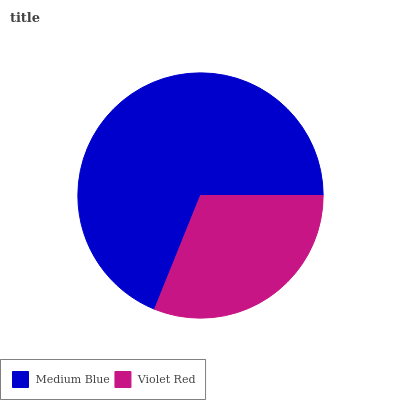Is Violet Red the minimum?
Answer yes or no. Yes. Is Medium Blue the maximum?
Answer yes or no. Yes. Is Violet Red the maximum?
Answer yes or no. No. Is Medium Blue greater than Violet Red?
Answer yes or no. Yes. Is Violet Red less than Medium Blue?
Answer yes or no. Yes. Is Violet Red greater than Medium Blue?
Answer yes or no. No. Is Medium Blue less than Violet Red?
Answer yes or no. No. Is Medium Blue the high median?
Answer yes or no. Yes. Is Violet Red the low median?
Answer yes or no. Yes. Is Violet Red the high median?
Answer yes or no. No. Is Medium Blue the low median?
Answer yes or no. No. 